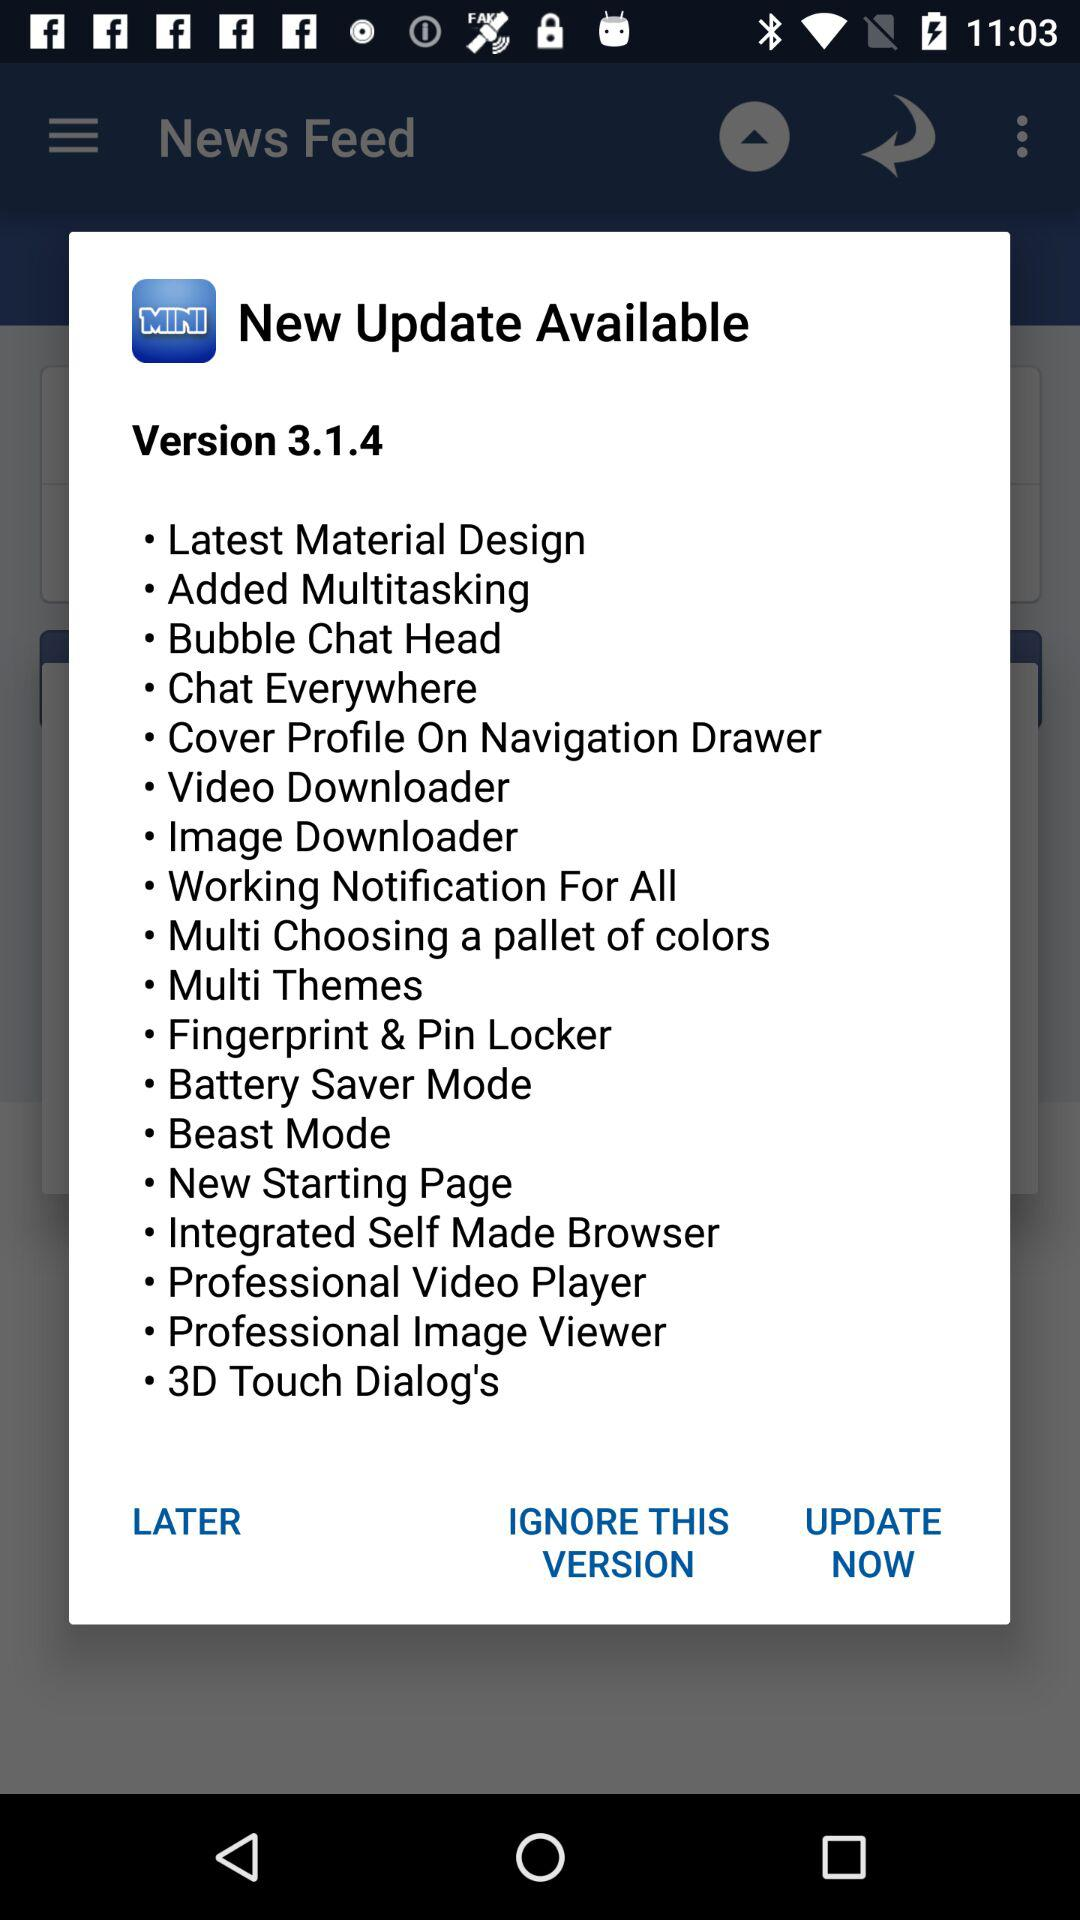What is the new update in version 3.1.4? The new updates are "Latest Material Design", "Added Multitasking", "Bubble Chat Head", "Chat Everywhere", "Cover Profile On Navigation Drawer", "Video Downloader", "Image Downloader", "Working Notification For All", "Multi Choosing a pallet of colors", "Multi Themes", "Fingerprint & Pin Locker", "Battery Saver Mode", "Beast Mode", "New Starting Page", "Integrated Self Made Browser", "Professional Video Player", "Professional Image Viewer" and "3D Touch Dialog's". 